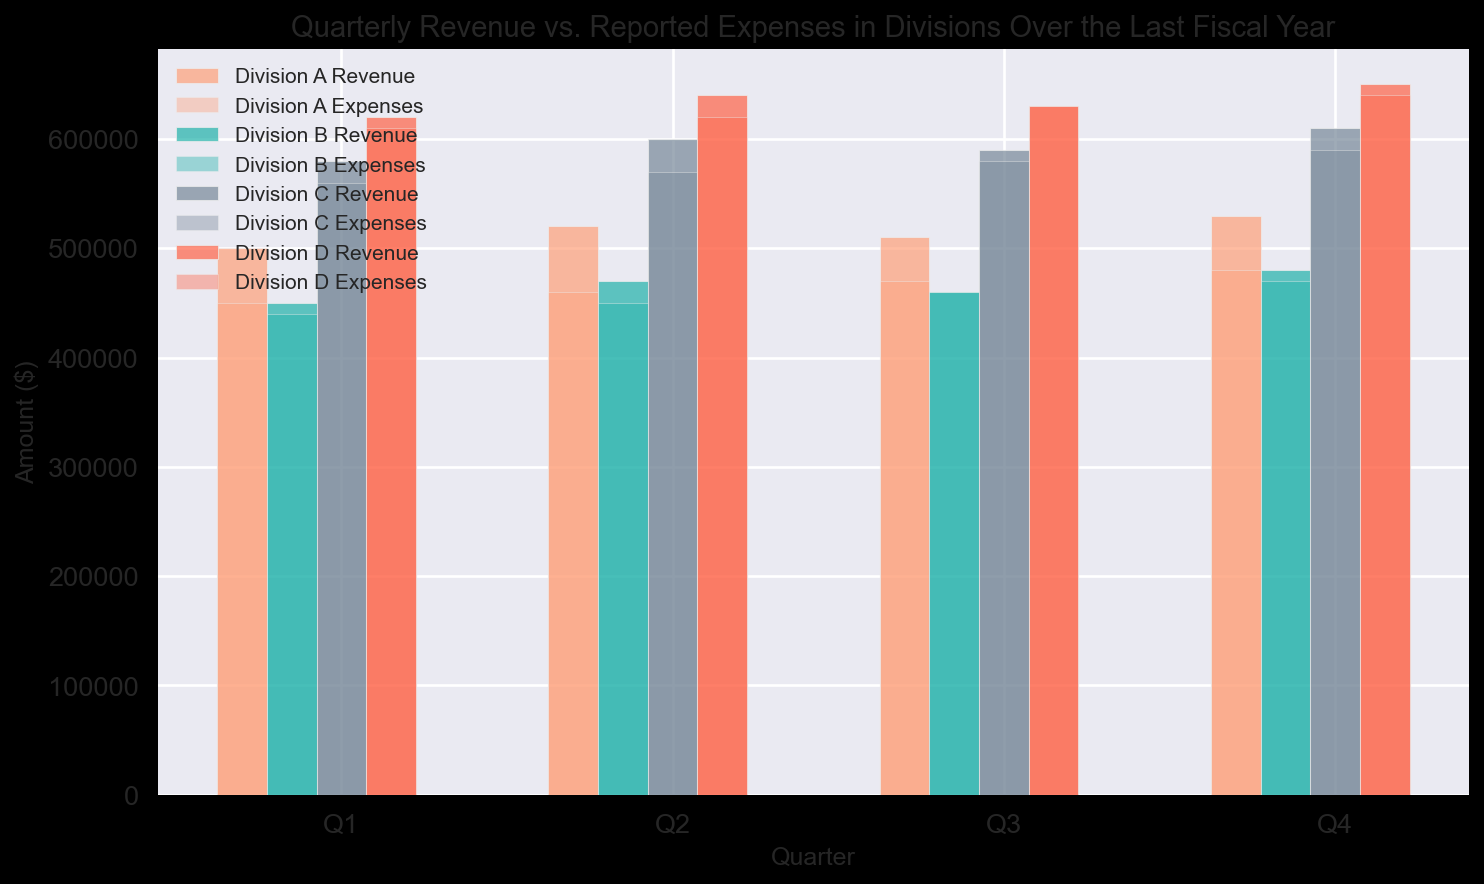Which division had the highest overall revenue in Q4? To find the division with the highest overall revenue in Q4, look at the height of the bars representing Q4 revenue for each division. Identify the tallest bar among them, which corresponds to Division D.
Answer: Division D How did the expenses of Division C in Q1 compare to those in Q2? Compare the height of the bars representing the expenses for Division C in Q1 and Q2. The bar for Q2 is slightly higher than the one for Q1, indicating that expenses were higher in Q2.
Answer: Higher in Q2 What is the average revenue of Division B across all quarters? To find the average revenue, sum the quarterly revenues of Division B (450000 + 470000 + 460000 + 480000) and divide by the number of quarters (4). This calculation yields an average revenue of 465000.
Answer: 465000 Which division had the closest expenses to its revenue in Q3? Compare the expenses and revenue bars for each division in Q3. The difference between the values is the smallest for Division B at Q3.
Answer: Division B Did any division have consistently increasing revenue each quarter? Check the pattern of the revenue bars for each division. Division A and Division D show a consistent increase in revenue from Q1 to Q4.
Answer: Division A and Division D Which division had the largest difference between revenue and expenses in Q1? Calculate the difference between revenue and expenses for each division in Q1. Division C has the largest gap with (580000 - 560000) = 20000.
Answer: Division C What trend can be observed in Division D's expenses throughout the year? Observe the height of the expenses bars for Division D across all quarters. The expenses show a consistent increase from Q1 to Q4.
Answer: Increasing By how much did the revenue of Division A increase from Q1 to Q4? Subtract the revenue of Division A in Q1 from that in Q4 (530000 - 500000), yielding an increase of 30000.
Answer: 30000 Which quarters had equal revenue and expenses for any division? Look for bars representing revenue and expenses that are of equal height. Division B in Q3 and Division D in Q3 both had equal revenue and expenses.
Answer: Q3 for Divisions B and D How much more revenue did Division C generate compared to Division B in Q2? Subtract the revenue of Division B in Q2 from that of Division C in Q2 (600000 - 470000), resulting in a difference of 130000.
Answer: 130000 